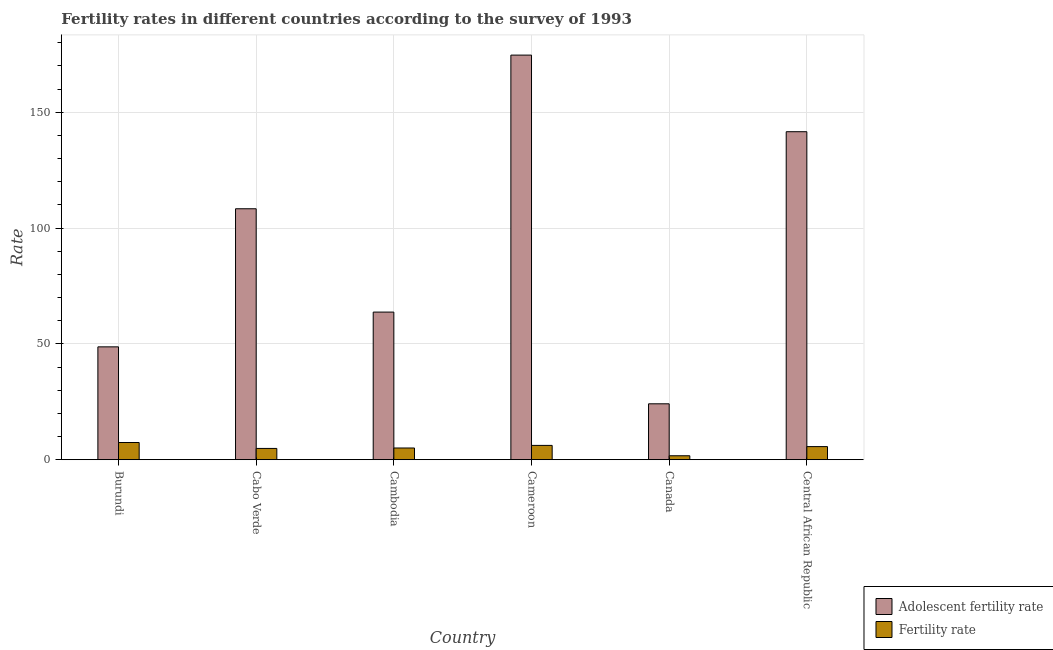How many groups of bars are there?
Provide a succinct answer. 6. Are the number of bars on each tick of the X-axis equal?
Your answer should be very brief. Yes. What is the label of the 3rd group of bars from the left?
Offer a terse response. Cambodia. In how many cases, is the number of bars for a given country not equal to the number of legend labels?
Provide a succinct answer. 0. What is the fertility rate in Cameroon?
Make the answer very short. 6.17. Across all countries, what is the maximum adolescent fertility rate?
Give a very brief answer. 174.67. Across all countries, what is the minimum adolescent fertility rate?
Your response must be concise. 24.13. In which country was the adolescent fertility rate maximum?
Offer a very short reply. Cameroon. In which country was the fertility rate minimum?
Make the answer very short. Canada. What is the total fertility rate in the graph?
Provide a short and direct response. 30.86. What is the difference between the adolescent fertility rate in Cabo Verde and that in Canada?
Offer a very short reply. 84.2. What is the difference between the fertility rate in Cambodia and the adolescent fertility rate in Canada?
Your response must be concise. -19.08. What is the average adolescent fertility rate per country?
Provide a short and direct response. 93.53. What is the difference between the fertility rate and adolescent fertility rate in Cabo Verde?
Make the answer very short. -103.47. In how many countries, is the fertility rate greater than 160 ?
Give a very brief answer. 0. What is the ratio of the fertility rate in Cabo Verde to that in Cambodia?
Your answer should be very brief. 0.96. Is the difference between the fertility rate in Cabo Verde and Central African Republic greater than the difference between the adolescent fertility rate in Cabo Verde and Central African Republic?
Make the answer very short. Yes. What is the difference between the highest and the second highest fertility rate?
Offer a terse response. 1.24. What is the difference between the highest and the lowest fertility rate?
Offer a very short reply. 5.72. What does the 1st bar from the left in Central African Republic represents?
Your answer should be very brief. Adolescent fertility rate. What does the 2nd bar from the right in Burundi represents?
Keep it short and to the point. Adolescent fertility rate. How many countries are there in the graph?
Give a very brief answer. 6. Are the values on the major ticks of Y-axis written in scientific E-notation?
Offer a terse response. No. Where does the legend appear in the graph?
Provide a short and direct response. Bottom right. How many legend labels are there?
Your response must be concise. 2. What is the title of the graph?
Your answer should be compact. Fertility rates in different countries according to the survey of 1993. What is the label or title of the X-axis?
Your response must be concise. Country. What is the label or title of the Y-axis?
Provide a succinct answer. Rate. What is the Rate in Adolescent fertility rate in Burundi?
Provide a short and direct response. 48.72. What is the Rate in Fertility rate in Burundi?
Your response must be concise. 7.42. What is the Rate of Adolescent fertility rate in Cabo Verde?
Make the answer very short. 108.33. What is the Rate of Fertility rate in Cabo Verde?
Ensure brevity in your answer.  4.87. What is the Rate of Adolescent fertility rate in Cambodia?
Offer a terse response. 63.73. What is the Rate in Fertility rate in Cambodia?
Keep it short and to the point. 5.05. What is the Rate of Adolescent fertility rate in Cameroon?
Give a very brief answer. 174.67. What is the Rate in Fertility rate in Cameroon?
Your response must be concise. 6.17. What is the Rate of Adolescent fertility rate in Canada?
Provide a short and direct response. 24.13. What is the Rate in Fertility rate in Canada?
Your response must be concise. 1.7. What is the Rate of Adolescent fertility rate in Central African Republic?
Ensure brevity in your answer.  141.6. What is the Rate in Fertility rate in Central African Republic?
Keep it short and to the point. 5.65. Across all countries, what is the maximum Rate of Adolescent fertility rate?
Ensure brevity in your answer.  174.67. Across all countries, what is the maximum Rate of Fertility rate?
Offer a terse response. 7.42. Across all countries, what is the minimum Rate in Adolescent fertility rate?
Provide a succinct answer. 24.13. Across all countries, what is the minimum Rate of Fertility rate?
Offer a very short reply. 1.7. What is the total Rate of Adolescent fertility rate in the graph?
Your answer should be compact. 561.18. What is the total Rate of Fertility rate in the graph?
Provide a succinct answer. 30.86. What is the difference between the Rate in Adolescent fertility rate in Burundi and that in Cabo Verde?
Provide a short and direct response. -59.62. What is the difference between the Rate in Fertility rate in Burundi and that in Cabo Verde?
Your answer should be compact. 2.55. What is the difference between the Rate of Adolescent fertility rate in Burundi and that in Cambodia?
Offer a very short reply. -15.01. What is the difference between the Rate of Fertility rate in Burundi and that in Cambodia?
Make the answer very short. 2.37. What is the difference between the Rate in Adolescent fertility rate in Burundi and that in Cameroon?
Your answer should be very brief. -125.95. What is the difference between the Rate of Fertility rate in Burundi and that in Cameroon?
Your response must be concise. 1.25. What is the difference between the Rate in Adolescent fertility rate in Burundi and that in Canada?
Provide a succinct answer. 24.59. What is the difference between the Rate in Fertility rate in Burundi and that in Canada?
Ensure brevity in your answer.  5.72. What is the difference between the Rate in Adolescent fertility rate in Burundi and that in Central African Republic?
Keep it short and to the point. -92.88. What is the difference between the Rate of Fertility rate in Burundi and that in Central African Republic?
Provide a short and direct response. 1.76. What is the difference between the Rate in Adolescent fertility rate in Cabo Verde and that in Cambodia?
Keep it short and to the point. 44.61. What is the difference between the Rate in Fertility rate in Cabo Verde and that in Cambodia?
Ensure brevity in your answer.  -0.19. What is the difference between the Rate in Adolescent fertility rate in Cabo Verde and that in Cameroon?
Provide a succinct answer. -66.34. What is the difference between the Rate of Fertility rate in Cabo Verde and that in Cameroon?
Give a very brief answer. -1.31. What is the difference between the Rate in Adolescent fertility rate in Cabo Verde and that in Canada?
Your response must be concise. 84.2. What is the difference between the Rate of Fertility rate in Cabo Verde and that in Canada?
Provide a short and direct response. 3.17. What is the difference between the Rate of Adolescent fertility rate in Cabo Verde and that in Central African Republic?
Your answer should be compact. -33.26. What is the difference between the Rate in Fertility rate in Cabo Verde and that in Central African Republic?
Make the answer very short. -0.79. What is the difference between the Rate of Adolescent fertility rate in Cambodia and that in Cameroon?
Keep it short and to the point. -110.94. What is the difference between the Rate of Fertility rate in Cambodia and that in Cameroon?
Offer a very short reply. -1.12. What is the difference between the Rate of Adolescent fertility rate in Cambodia and that in Canada?
Your answer should be very brief. 39.59. What is the difference between the Rate of Fertility rate in Cambodia and that in Canada?
Offer a very short reply. 3.35. What is the difference between the Rate of Adolescent fertility rate in Cambodia and that in Central African Republic?
Your answer should be very brief. -77.87. What is the difference between the Rate in Fertility rate in Cambodia and that in Central African Republic?
Offer a terse response. -0.6. What is the difference between the Rate in Adolescent fertility rate in Cameroon and that in Canada?
Provide a short and direct response. 150.54. What is the difference between the Rate of Fertility rate in Cameroon and that in Canada?
Provide a succinct answer. 4.47. What is the difference between the Rate in Adolescent fertility rate in Cameroon and that in Central African Republic?
Keep it short and to the point. 33.07. What is the difference between the Rate in Fertility rate in Cameroon and that in Central African Republic?
Give a very brief answer. 0.52. What is the difference between the Rate of Adolescent fertility rate in Canada and that in Central African Republic?
Your answer should be very brief. -117.46. What is the difference between the Rate of Fertility rate in Canada and that in Central African Republic?
Give a very brief answer. -3.95. What is the difference between the Rate in Adolescent fertility rate in Burundi and the Rate in Fertility rate in Cabo Verde?
Provide a succinct answer. 43.85. What is the difference between the Rate in Adolescent fertility rate in Burundi and the Rate in Fertility rate in Cambodia?
Give a very brief answer. 43.67. What is the difference between the Rate in Adolescent fertility rate in Burundi and the Rate in Fertility rate in Cameroon?
Your answer should be very brief. 42.55. What is the difference between the Rate in Adolescent fertility rate in Burundi and the Rate in Fertility rate in Canada?
Offer a terse response. 47.02. What is the difference between the Rate of Adolescent fertility rate in Burundi and the Rate of Fertility rate in Central African Republic?
Your answer should be compact. 43.07. What is the difference between the Rate in Adolescent fertility rate in Cabo Verde and the Rate in Fertility rate in Cambodia?
Your answer should be very brief. 103.28. What is the difference between the Rate in Adolescent fertility rate in Cabo Verde and the Rate in Fertility rate in Cameroon?
Keep it short and to the point. 102.16. What is the difference between the Rate in Adolescent fertility rate in Cabo Verde and the Rate in Fertility rate in Canada?
Your answer should be very brief. 106.63. What is the difference between the Rate of Adolescent fertility rate in Cabo Verde and the Rate of Fertility rate in Central African Republic?
Offer a terse response. 102.68. What is the difference between the Rate of Adolescent fertility rate in Cambodia and the Rate of Fertility rate in Cameroon?
Offer a terse response. 57.55. What is the difference between the Rate of Adolescent fertility rate in Cambodia and the Rate of Fertility rate in Canada?
Make the answer very short. 62.03. What is the difference between the Rate in Adolescent fertility rate in Cambodia and the Rate in Fertility rate in Central African Republic?
Give a very brief answer. 58.07. What is the difference between the Rate in Adolescent fertility rate in Cameroon and the Rate in Fertility rate in Canada?
Your response must be concise. 172.97. What is the difference between the Rate in Adolescent fertility rate in Cameroon and the Rate in Fertility rate in Central African Republic?
Your answer should be compact. 169.02. What is the difference between the Rate of Adolescent fertility rate in Canada and the Rate of Fertility rate in Central African Republic?
Provide a succinct answer. 18.48. What is the average Rate of Adolescent fertility rate per country?
Your answer should be compact. 93.53. What is the average Rate of Fertility rate per country?
Make the answer very short. 5.14. What is the difference between the Rate of Adolescent fertility rate and Rate of Fertility rate in Burundi?
Ensure brevity in your answer.  41.3. What is the difference between the Rate of Adolescent fertility rate and Rate of Fertility rate in Cabo Verde?
Keep it short and to the point. 103.47. What is the difference between the Rate of Adolescent fertility rate and Rate of Fertility rate in Cambodia?
Give a very brief answer. 58.67. What is the difference between the Rate in Adolescent fertility rate and Rate in Fertility rate in Cameroon?
Provide a succinct answer. 168.5. What is the difference between the Rate in Adolescent fertility rate and Rate in Fertility rate in Canada?
Offer a very short reply. 22.43. What is the difference between the Rate of Adolescent fertility rate and Rate of Fertility rate in Central African Republic?
Offer a terse response. 135.94. What is the ratio of the Rate in Adolescent fertility rate in Burundi to that in Cabo Verde?
Make the answer very short. 0.45. What is the ratio of the Rate of Fertility rate in Burundi to that in Cabo Verde?
Provide a short and direct response. 1.52. What is the ratio of the Rate in Adolescent fertility rate in Burundi to that in Cambodia?
Your answer should be very brief. 0.76. What is the ratio of the Rate in Fertility rate in Burundi to that in Cambodia?
Your response must be concise. 1.47. What is the ratio of the Rate in Adolescent fertility rate in Burundi to that in Cameroon?
Your answer should be very brief. 0.28. What is the ratio of the Rate of Fertility rate in Burundi to that in Cameroon?
Offer a terse response. 1.2. What is the ratio of the Rate of Adolescent fertility rate in Burundi to that in Canada?
Make the answer very short. 2.02. What is the ratio of the Rate in Fertility rate in Burundi to that in Canada?
Your response must be concise. 4.36. What is the ratio of the Rate in Adolescent fertility rate in Burundi to that in Central African Republic?
Offer a terse response. 0.34. What is the ratio of the Rate in Fertility rate in Burundi to that in Central African Republic?
Your answer should be compact. 1.31. What is the ratio of the Rate in Adolescent fertility rate in Cabo Verde to that in Cambodia?
Your response must be concise. 1.7. What is the ratio of the Rate in Fertility rate in Cabo Verde to that in Cambodia?
Your answer should be very brief. 0.96. What is the ratio of the Rate of Adolescent fertility rate in Cabo Verde to that in Cameroon?
Ensure brevity in your answer.  0.62. What is the ratio of the Rate in Fertility rate in Cabo Verde to that in Cameroon?
Offer a very short reply. 0.79. What is the ratio of the Rate in Adolescent fertility rate in Cabo Verde to that in Canada?
Ensure brevity in your answer.  4.49. What is the ratio of the Rate of Fertility rate in Cabo Verde to that in Canada?
Your response must be concise. 2.86. What is the ratio of the Rate of Adolescent fertility rate in Cabo Verde to that in Central African Republic?
Give a very brief answer. 0.77. What is the ratio of the Rate of Fertility rate in Cabo Verde to that in Central African Republic?
Keep it short and to the point. 0.86. What is the ratio of the Rate in Adolescent fertility rate in Cambodia to that in Cameroon?
Ensure brevity in your answer.  0.36. What is the ratio of the Rate of Fertility rate in Cambodia to that in Cameroon?
Make the answer very short. 0.82. What is the ratio of the Rate in Adolescent fertility rate in Cambodia to that in Canada?
Offer a terse response. 2.64. What is the ratio of the Rate of Fertility rate in Cambodia to that in Canada?
Provide a short and direct response. 2.97. What is the ratio of the Rate in Adolescent fertility rate in Cambodia to that in Central African Republic?
Provide a succinct answer. 0.45. What is the ratio of the Rate in Fertility rate in Cambodia to that in Central African Republic?
Offer a terse response. 0.89. What is the ratio of the Rate in Adolescent fertility rate in Cameroon to that in Canada?
Provide a short and direct response. 7.24. What is the ratio of the Rate of Fertility rate in Cameroon to that in Canada?
Keep it short and to the point. 3.63. What is the ratio of the Rate of Adolescent fertility rate in Cameroon to that in Central African Republic?
Make the answer very short. 1.23. What is the ratio of the Rate of Fertility rate in Cameroon to that in Central African Republic?
Your answer should be compact. 1.09. What is the ratio of the Rate in Adolescent fertility rate in Canada to that in Central African Republic?
Provide a short and direct response. 0.17. What is the ratio of the Rate in Fertility rate in Canada to that in Central African Republic?
Offer a very short reply. 0.3. What is the difference between the highest and the second highest Rate in Adolescent fertility rate?
Ensure brevity in your answer.  33.07. What is the difference between the highest and the second highest Rate of Fertility rate?
Offer a very short reply. 1.25. What is the difference between the highest and the lowest Rate of Adolescent fertility rate?
Provide a succinct answer. 150.54. What is the difference between the highest and the lowest Rate in Fertility rate?
Provide a succinct answer. 5.72. 